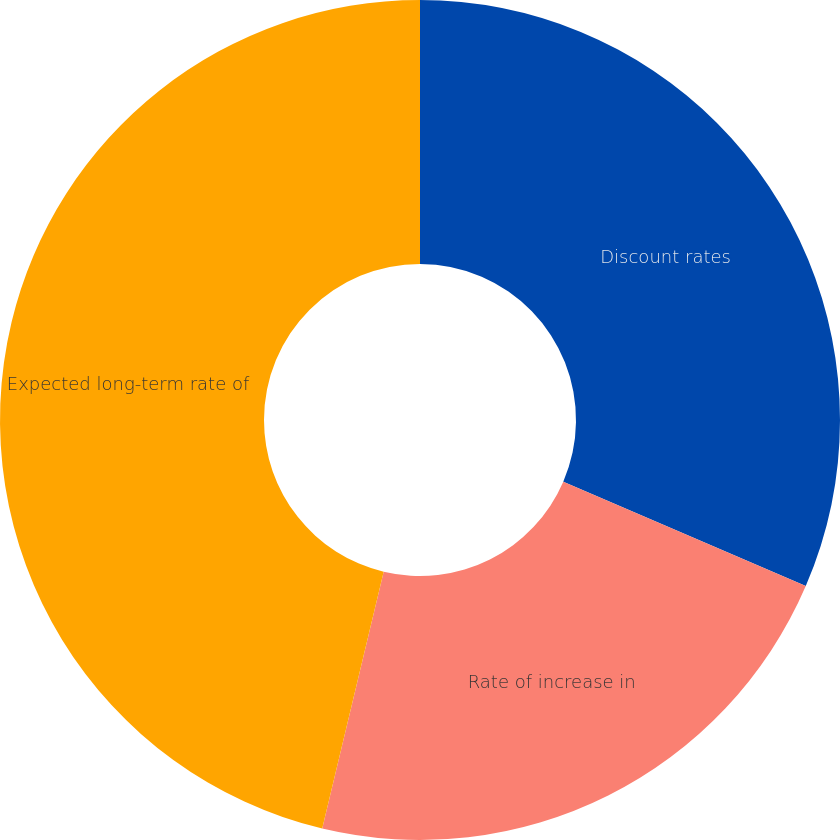Convert chart to OTSL. <chart><loc_0><loc_0><loc_500><loc_500><pie_chart><fcel>Discount rates<fcel>Rate of increase in<fcel>Expected long-term rate of<nl><fcel>31.47%<fcel>22.27%<fcel>46.26%<nl></chart> 